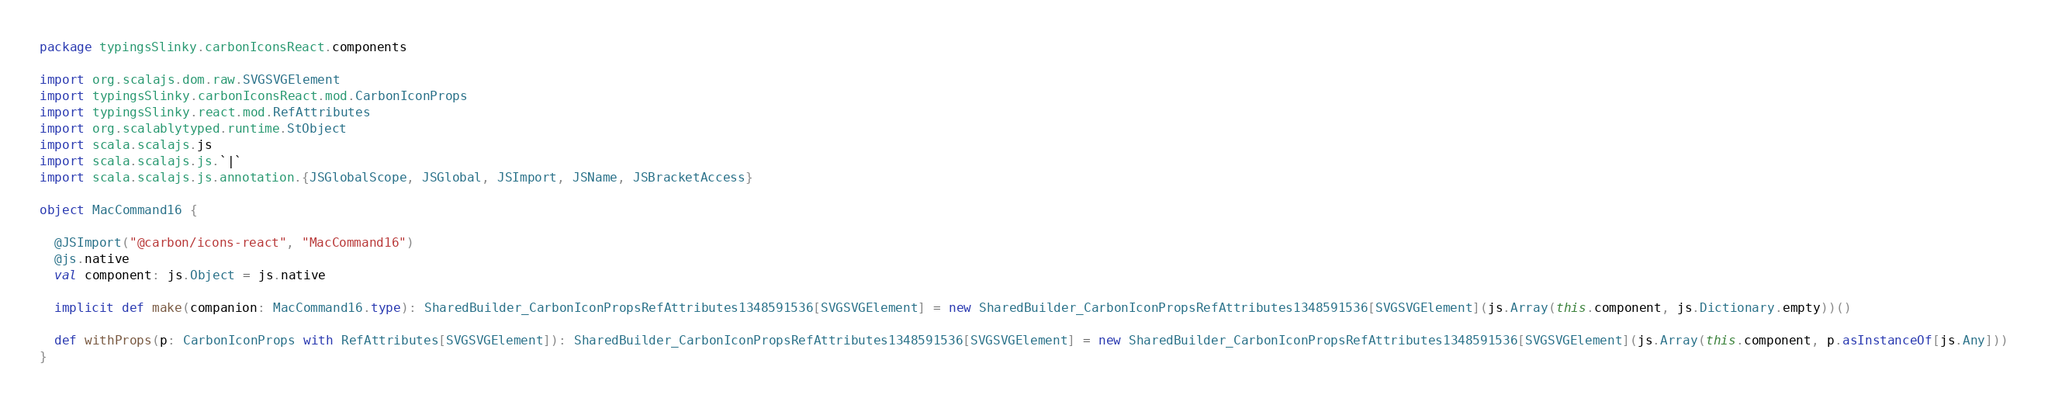<code> <loc_0><loc_0><loc_500><loc_500><_Scala_>package typingsSlinky.carbonIconsReact.components

import org.scalajs.dom.raw.SVGSVGElement
import typingsSlinky.carbonIconsReact.mod.CarbonIconProps
import typingsSlinky.react.mod.RefAttributes
import org.scalablytyped.runtime.StObject
import scala.scalajs.js
import scala.scalajs.js.`|`
import scala.scalajs.js.annotation.{JSGlobalScope, JSGlobal, JSImport, JSName, JSBracketAccess}

object MacCommand16 {
  
  @JSImport("@carbon/icons-react", "MacCommand16")
  @js.native
  val component: js.Object = js.native
  
  implicit def make(companion: MacCommand16.type): SharedBuilder_CarbonIconPropsRefAttributes1348591536[SVGSVGElement] = new SharedBuilder_CarbonIconPropsRefAttributes1348591536[SVGSVGElement](js.Array(this.component, js.Dictionary.empty))()
  
  def withProps(p: CarbonIconProps with RefAttributes[SVGSVGElement]): SharedBuilder_CarbonIconPropsRefAttributes1348591536[SVGSVGElement] = new SharedBuilder_CarbonIconPropsRefAttributes1348591536[SVGSVGElement](js.Array(this.component, p.asInstanceOf[js.Any]))
}
</code> 